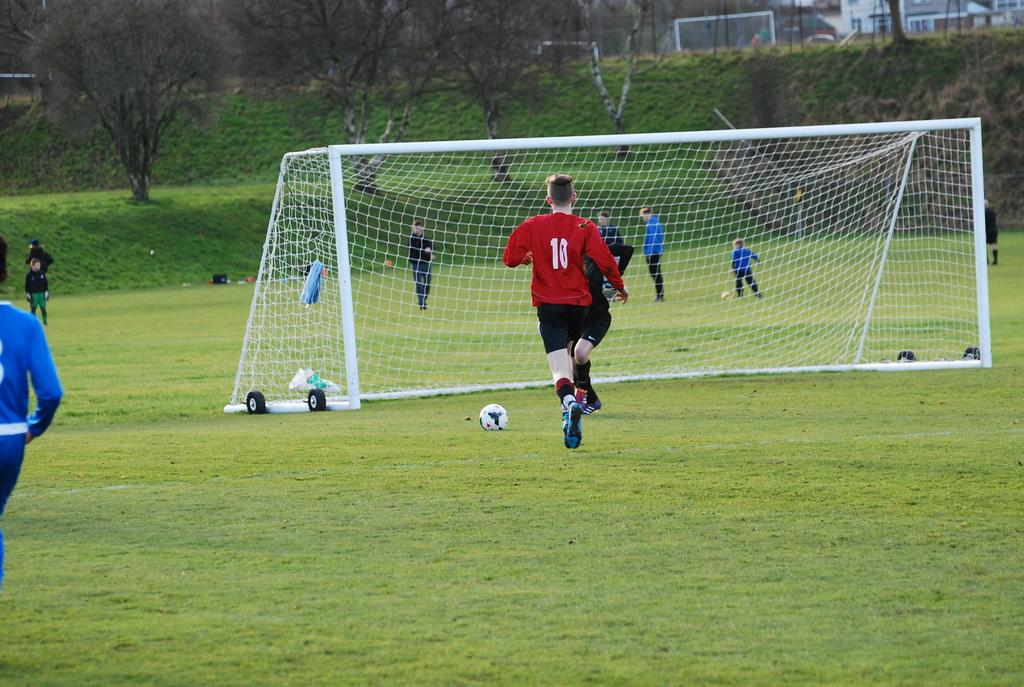<image>
Offer a succinct explanation of the picture presented. a soccer player wearing a shirt that has the number 10 on it 